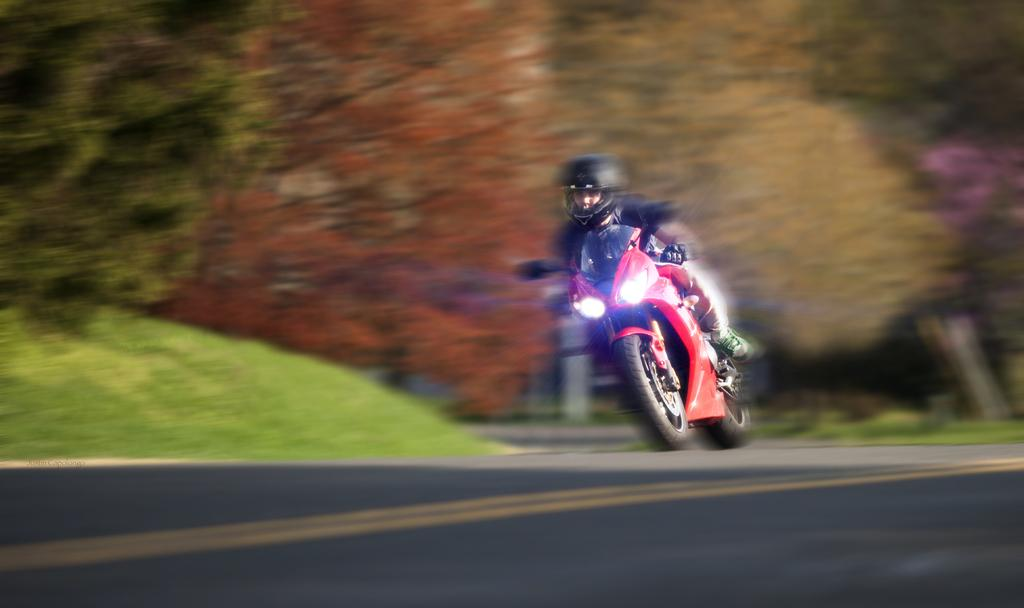What is the man in the image doing? The man is driving a bike in the image. What color is the bike the man is riding? The bike is red. What safety precaution is the man taking while riding the bike? The man is wearing a helmet. Where is the bike located in the image? The bike is on the road. What can be seen in the background of the image? There are trees in the background of the image. What type of drink is the man holding while riding the bike in the image? There is no drink visible in the image; the man is focused on driving the bike. 